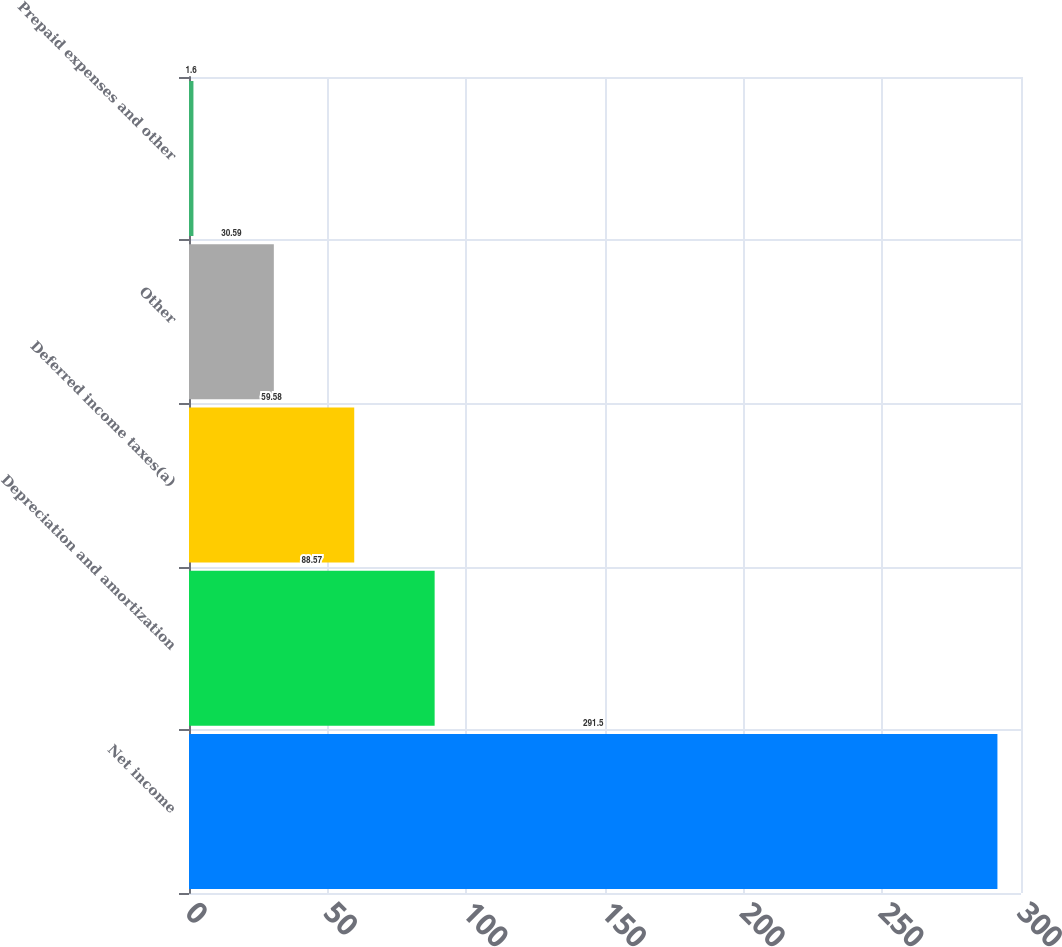Convert chart to OTSL. <chart><loc_0><loc_0><loc_500><loc_500><bar_chart><fcel>Net income<fcel>Depreciation and amortization<fcel>Deferred income taxes(a)<fcel>Other<fcel>Prepaid expenses and other<nl><fcel>291.5<fcel>88.57<fcel>59.58<fcel>30.59<fcel>1.6<nl></chart> 